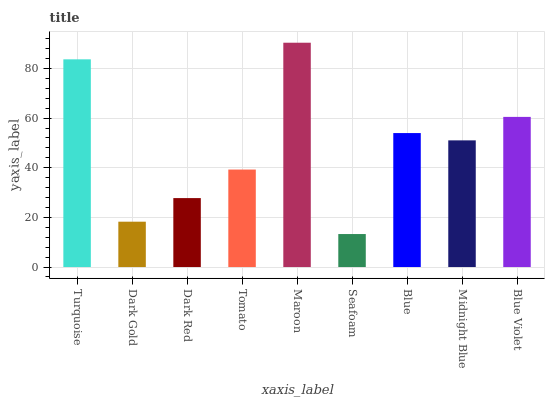Is Seafoam the minimum?
Answer yes or no. Yes. Is Maroon the maximum?
Answer yes or no. Yes. Is Dark Gold the minimum?
Answer yes or no. No. Is Dark Gold the maximum?
Answer yes or no. No. Is Turquoise greater than Dark Gold?
Answer yes or no. Yes. Is Dark Gold less than Turquoise?
Answer yes or no. Yes. Is Dark Gold greater than Turquoise?
Answer yes or no. No. Is Turquoise less than Dark Gold?
Answer yes or no. No. Is Midnight Blue the high median?
Answer yes or no. Yes. Is Midnight Blue the low median?
Answer yes or no. Yes. Is Turquoise the high median?
Answer yes or no. No. Is Blue the low median?
Answer yes or no. No. 